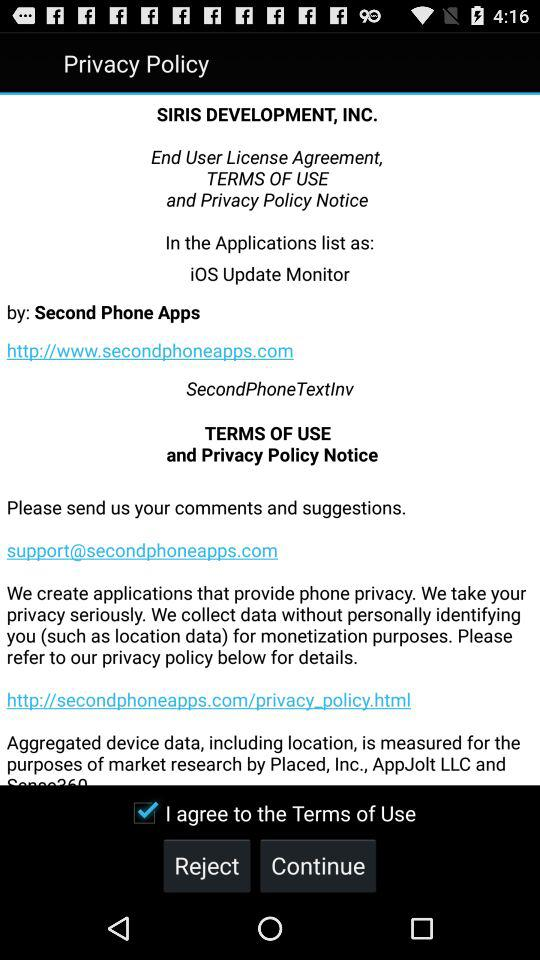What is the URL for the application? The URL is http://www.secondphoneapps.com. 